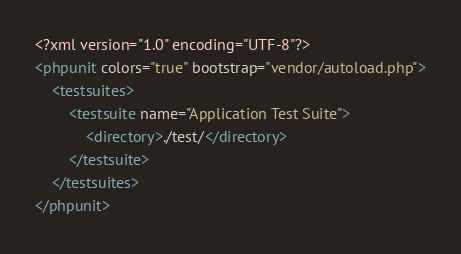Convert code to text. <code><loc_0><loc_0><loc_500><loc_500><_XML_><?xml version="1.0" encoding="UTF-8"?>
<phpunit colors="true" bootstrap="vendor/autoload.php">
    <testsuites>
        <testsuite name="Application Test Suite">
            <directory>./test/</directory>
        </testsuite>
    </testsuites>
</phpunit>
</code> 